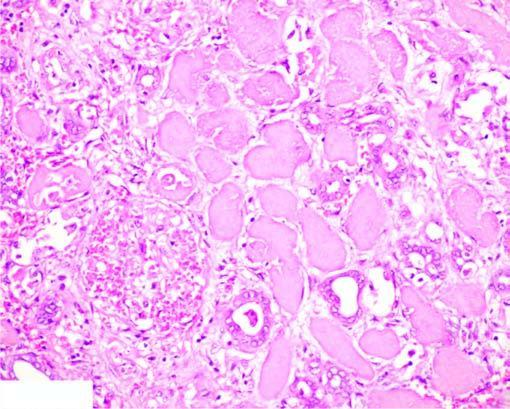what are still maintained?
Answer the question using a single word or phrase. The outlines of tubules 